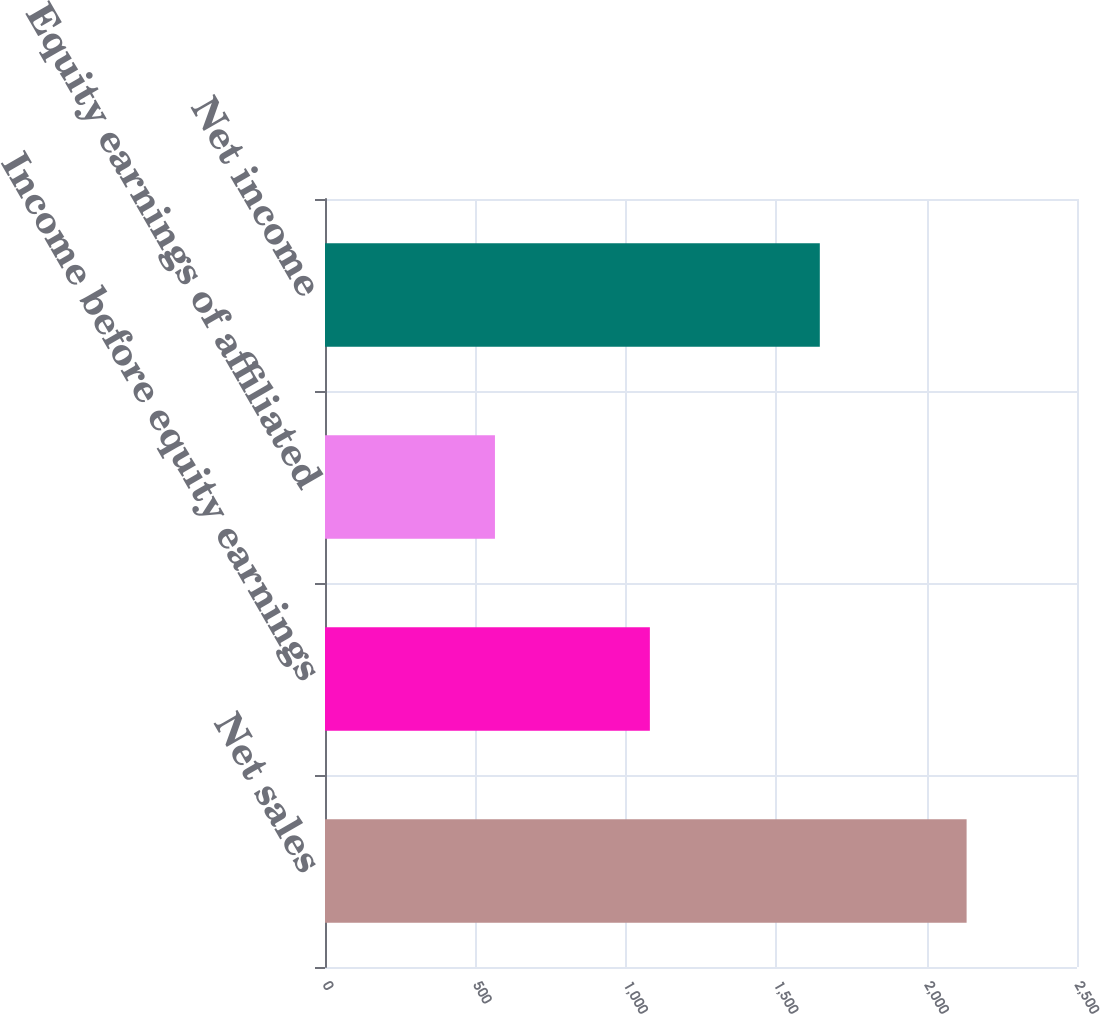Convert chart. <chart><loc_0><loc_0><loc_500><loc_500><bar_chart><fcel>Net sales<fcel>Income before equity earnings<fcel>Equity earnings of affiliated<fcel>Net income<nl><fcel>2133<fcel>1080<fcel>565<fcel>1645<nl></chart> 